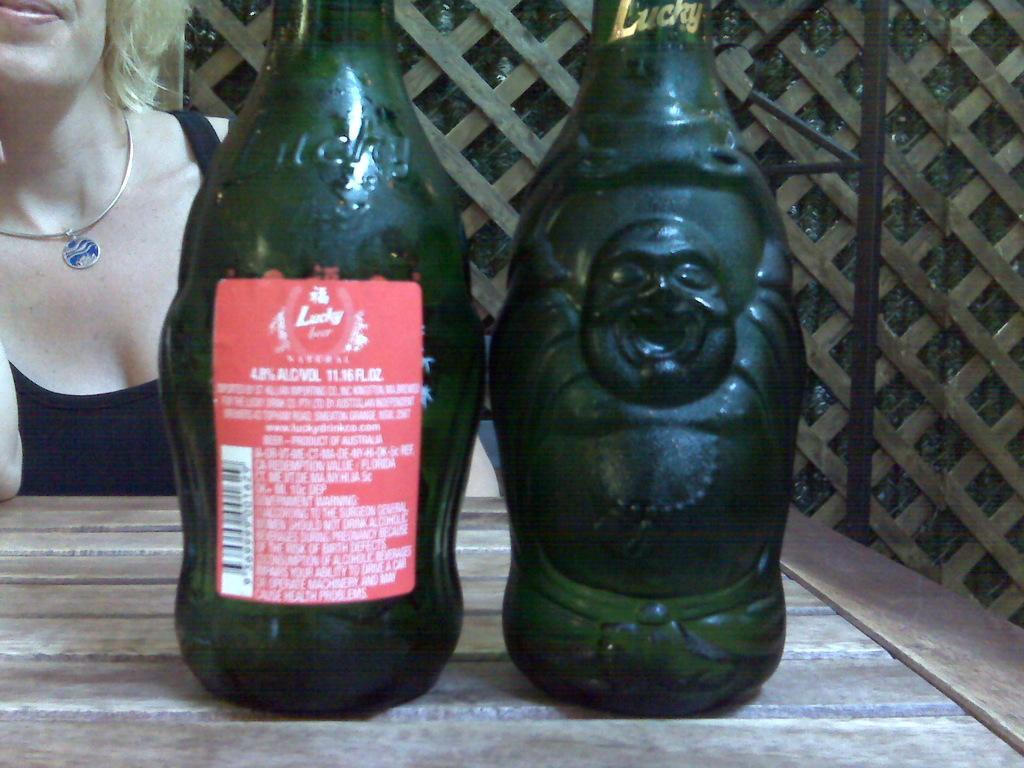In one or two sentences, can you explain what this image depicts? This image is clicked near the, in the room. There is a table placed two bottles are placed on the table and on the left side there is a woman sitting. She is wearing chain. She is wearing black t shirt. 